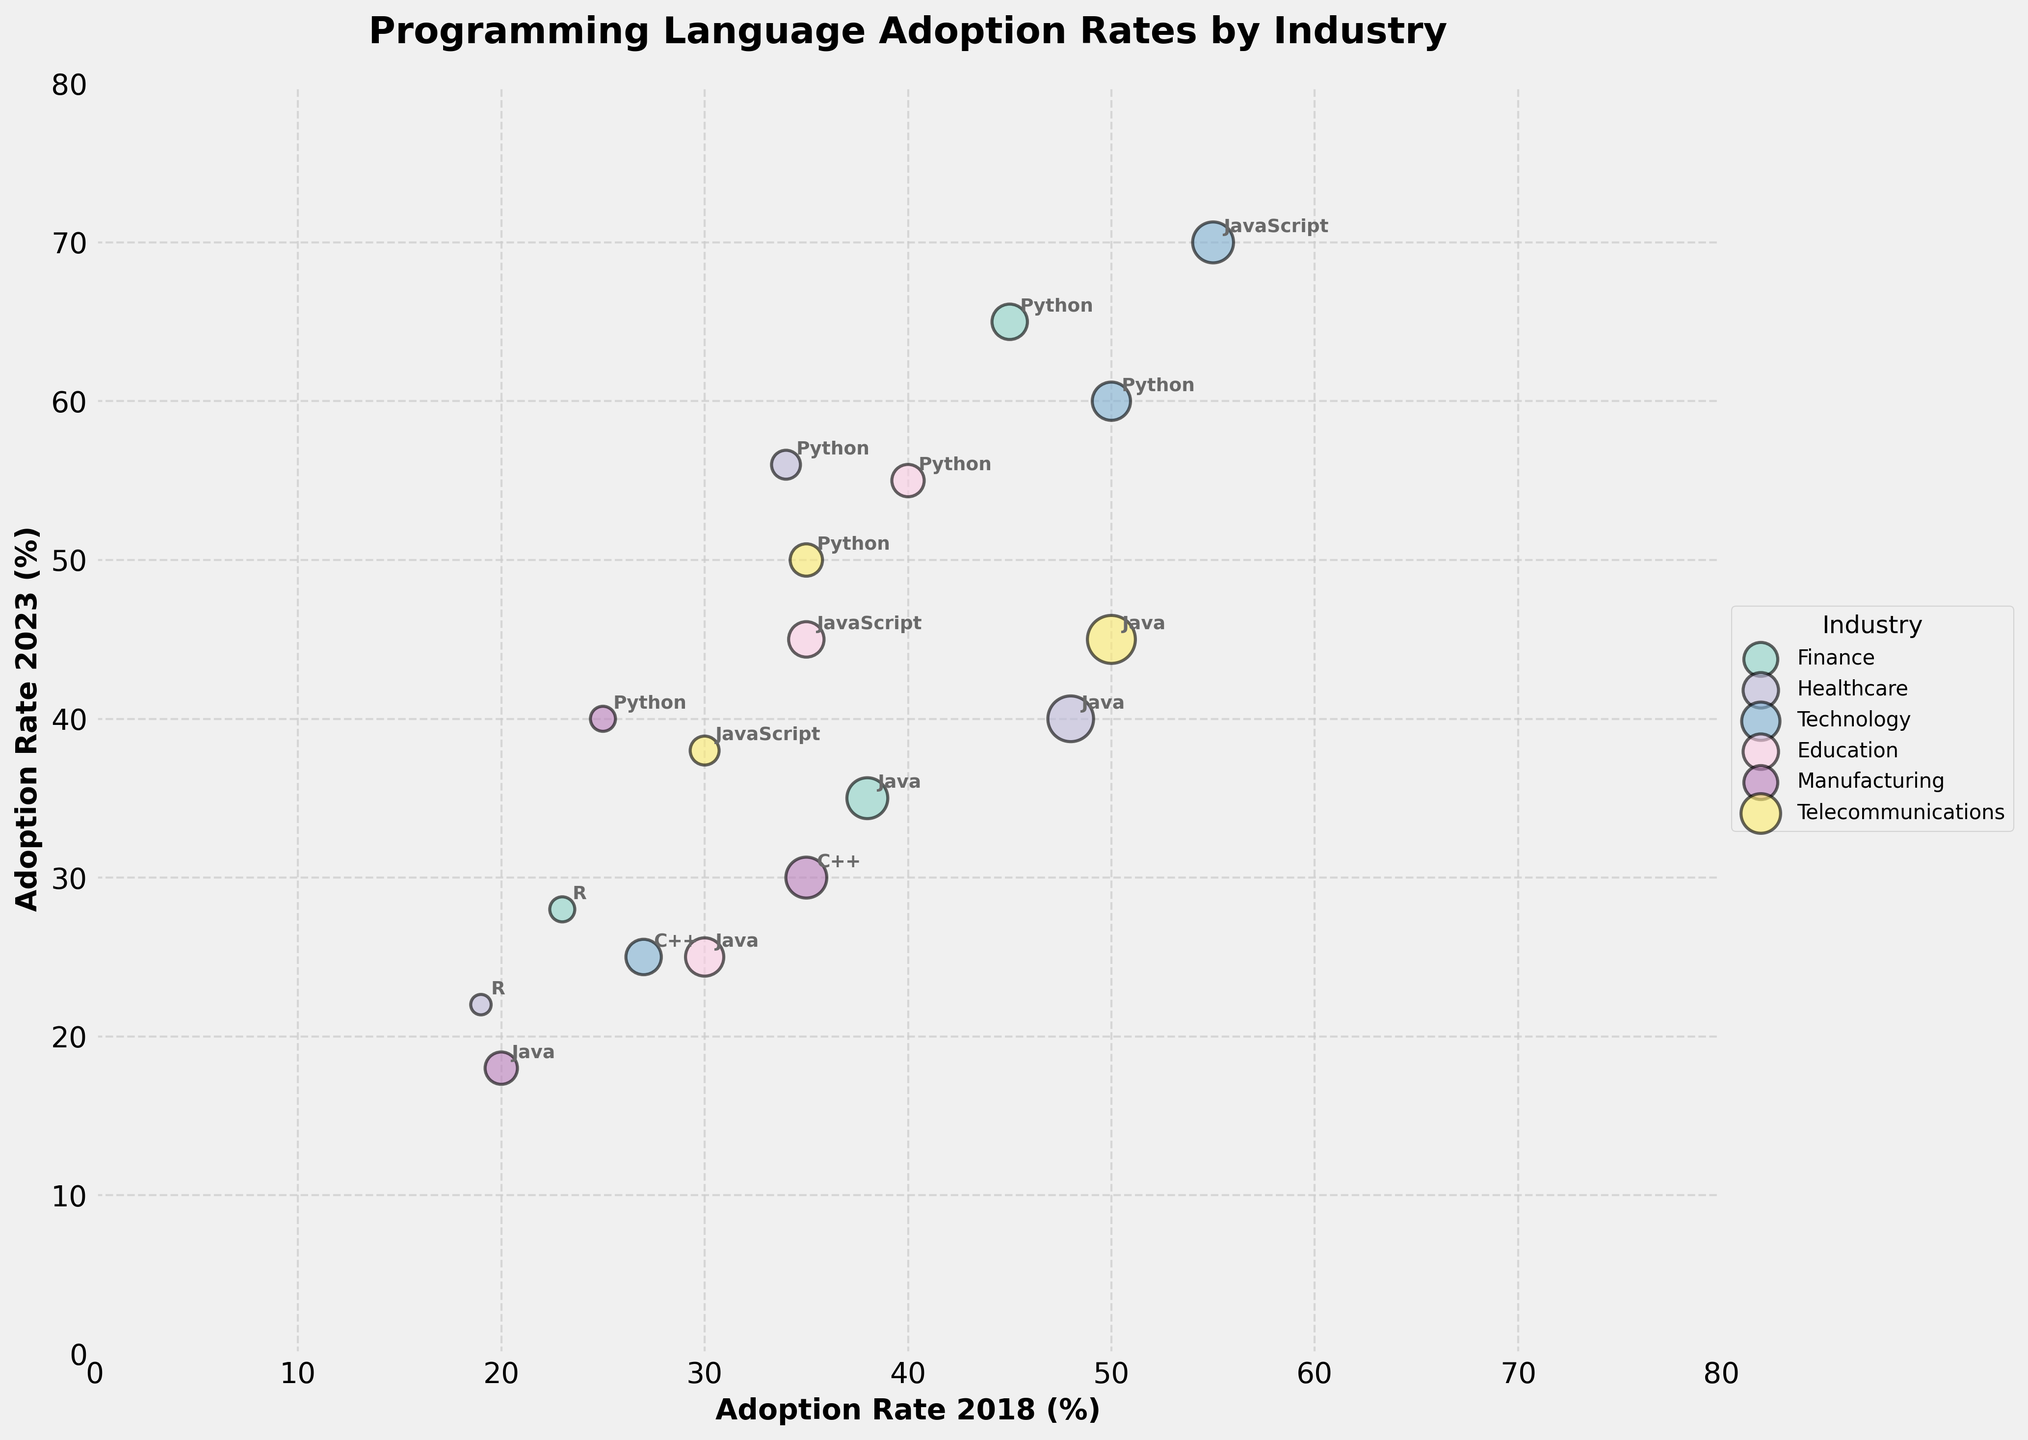What is the title of the figure? The title is usually displayed at the top of the figure. In this case, the title "Programming Language Adoption Rates by Industry" helps to identify the subject of the bubble chart.
Answer: Programming Language Adoption Rates by Industry Which industry has the highest adoption rate of Python in 2023? To find this, examine where the Python bubbles (annotated within each industry) are on the y-axis (2023 adoption rate). The highest y-value among Python bubbles is in the Finance industry at 65%.
Answer: Finance How many industries are represented in the chart? Each unique color in the legend and the chart corresponds to a different industry. By counting the legend entries, we can determine the number of industries. There are six entries in the legend.
Answer: Six What industry had the highest adoption rate for Java in 2018? Look for the Java bubbles and identify their position on the x-axis (2018 adoption rate). The highest x-value among Java bubbles is in Telecommunications at 50%.
Answer: Telecommunications Which programming language in the Technology industry had the lowest adoption rate in 2013? Focus on the Technology bubbles and examine the size of each. The smallest bubble, indicating the lowest adoption rate in 2013, belongs to C++ (smallest size = 30%).
Answer: C++ Compare the adoption rates of Python in the Healthcare and Education industries in 2023. Which industry has a higher adoption rate? Compare the y-values of the Python bubbles for Healthcare and Education. Healthcare has a y-value of 56, while Education has 55.
Answer: Healthcare Which industry shows the largest increase in Python adoption rate from 2013 to 2023? Calculate the difference between the 2023 and 2013 adoption rates for Python in each industry. Finance: 65-30=35, Healthcare: 56-20=36, Technology: 60-35=25, Education: 55-25=30, Manufacturing: 40-15=25, Telecommunications: 50-25=25. Healthcare has the largest increase.
Answer: Healthcare What industry shows a decrease in Java adoption rate from 2018 to 2023, and what is the decrease amount? Look for Java bubbles that move left along the x-axis. Calculate the difference between the 2018 and 2023 rates. Finance: 38-35=3, Healthcare: 48-40=8, Education: 30-25=5, Manufacturing: 20-18=2, Telecommunications: 50-45=5. The highest decrease is in Healthcare, by 8%.
Answer: Healthcare, 8 Which programming languages in the Technology sector have increased their adoption rates from 2018 to 2023? Examine the Technology bubbles and note which ones move upward on the y-axis. JavaScript increases from 55 to 70, Python increases from 50 to 60. C++ decreases. So, JavaScript and Python have increased.
Answer: JavaScript, Python 